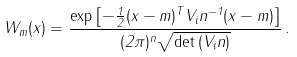Convert formula to latex. <formula><loc_0><loc_0><loc_500><loc_500>W _ { m } ( x ) = \frac { \exp { \left [ - \frac { 1 } { 2 } ( x - m ) ^ { T } V _ { i } n ^ { - 1 } ( x - m ) \right ] } } { ( 2 \pi ) ^ { n } \sqrt { \det { ( V _ { i } n ) } } } \, .</formula> 